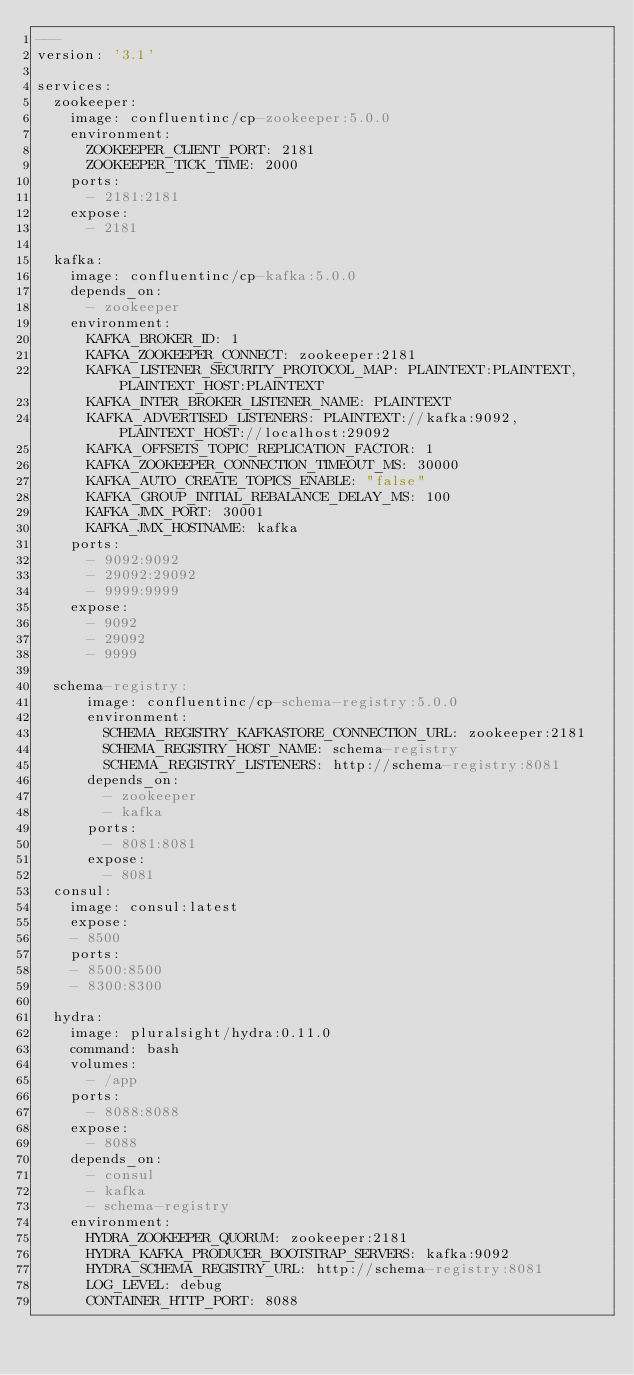<code> <loc_0><loc_0><loc_500><loc_500><_YAML_>---
version: '3.1'

services:
  zookeeper:
    image: confluentinc/cp-zookeeper:5.0.0
    environment:
      ZOOKEEPER_CLIENT_PORT: 2181
      ZOOKEEPER_TICK_TIME: 2000
    ports:
      - 2181:2181
    expose:
      - 2181

  kafka:
    image: confluentinc/cp-kafka:5.0.0
    depends_on:
      - zookeeper
    environment:
      KAFKA_BROKER_ID: 1
      KAFKA_ZOOKEEPER_CONNECT: zookeeper:2181
      KAFKA_LISTENER_SECURITY_PROTOCOL_MAP: PLAINTEXT:PLAINTEXT,PLAINTEXT_HOST:PLAINTEXT
      KAFKA_INTER_BROKER_LISTENER_NAME: PLAINTEXT
      KAFKA_ADVERTISED_LISTENERS: PLAINTEXT://kafka:9092,PLAINTEXT_HOST://localhost:29092
      KAFKA_OFFSETS_TOPIC_REPLICATION_FACTOR: 1
      KAFKA_ZOOKEEPER_CONNECTION_TIMEOUT_MS: 30000
      KAFKA_AUTO_CREATE_TOPICS_ENABLE: "false"
      KAFKA_GROUP_INITIAL_REBALANCE_DELAY_MS: 100
      KAFKA_JMX_PORT: 30001
      KAFKA_JMX_HOSTNAME: kafka
    ports:
      - 9092:9092
      - 29092:29092
      - 9999:9999
    expose:
      - 9092
      - 29092
      - 9999

  schema-registry:
      image: confluentinc/cp-schema-registry:5.0.0
      environment:
        SCHEMA_REGISTRY_KAFKASTORE_CONNECTION_URL: zookeeper:2181
        SCHEMA_REGISTRY_HOST_NAME: schema-registry
        SCHEMA_REGISTRY_LISTENERS: http://schema-registry:8081
      depends_on:
        - zookeeper
        - kafka
      ports:
        - 8081:8081
      expose:
        - 8081
  consul:
    image: consul:latest
    expose:
    - 8500
    ports:
    - 8500:8500
    - 8300:8300

  hydra:
    image: pluralsight/hydra:0.11.0
    command: bash
    volumes:
      - /app
    ports:
      - 8088:8088
    expose:
      - 8088
    depends_on:
      - consul
      - kafka
      - schema-registry
    environment:
      HYDRA_ZOOKEEPER_QUORUM: zookeeper:2181
      HYDRA_KAFKA_PRODUCER_BOOTSTRAP_SERVERS: kafka:9092
      HYDRA_SCHEMA_REGISTRY_URL: http://schema-registry:8081
      LOG_LEVEL: debug
      CONTAINER_HTTP_PORT: 8088</code> 